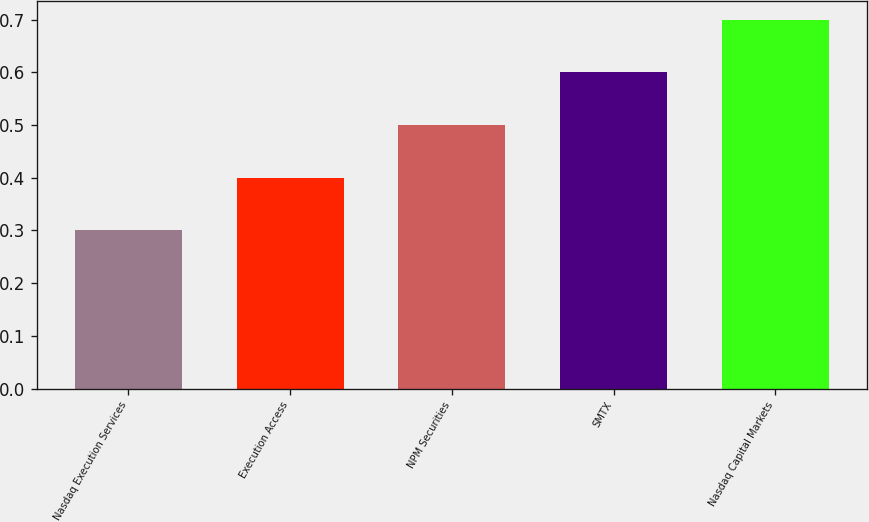<chart> <loc_0><loc_0><loc_500><loc_500><bar_chart><fcel>Nasdaq Execution Services<fcel>Execution Access<fcel>NPM Securities<fcel>SMTX<fcel>Nasdaq Capital Markets<nl><fcel>0.3<fcel>0.4<fcel>0.5<fcel>0.6<fcel>0.7<nl></chart> 